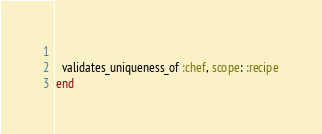<code> <loc_0><loc_0><loc_500><loc_500><_Ruby_>  
  validates_uniqueness_of :chef, scope: :recipe
end</code> 